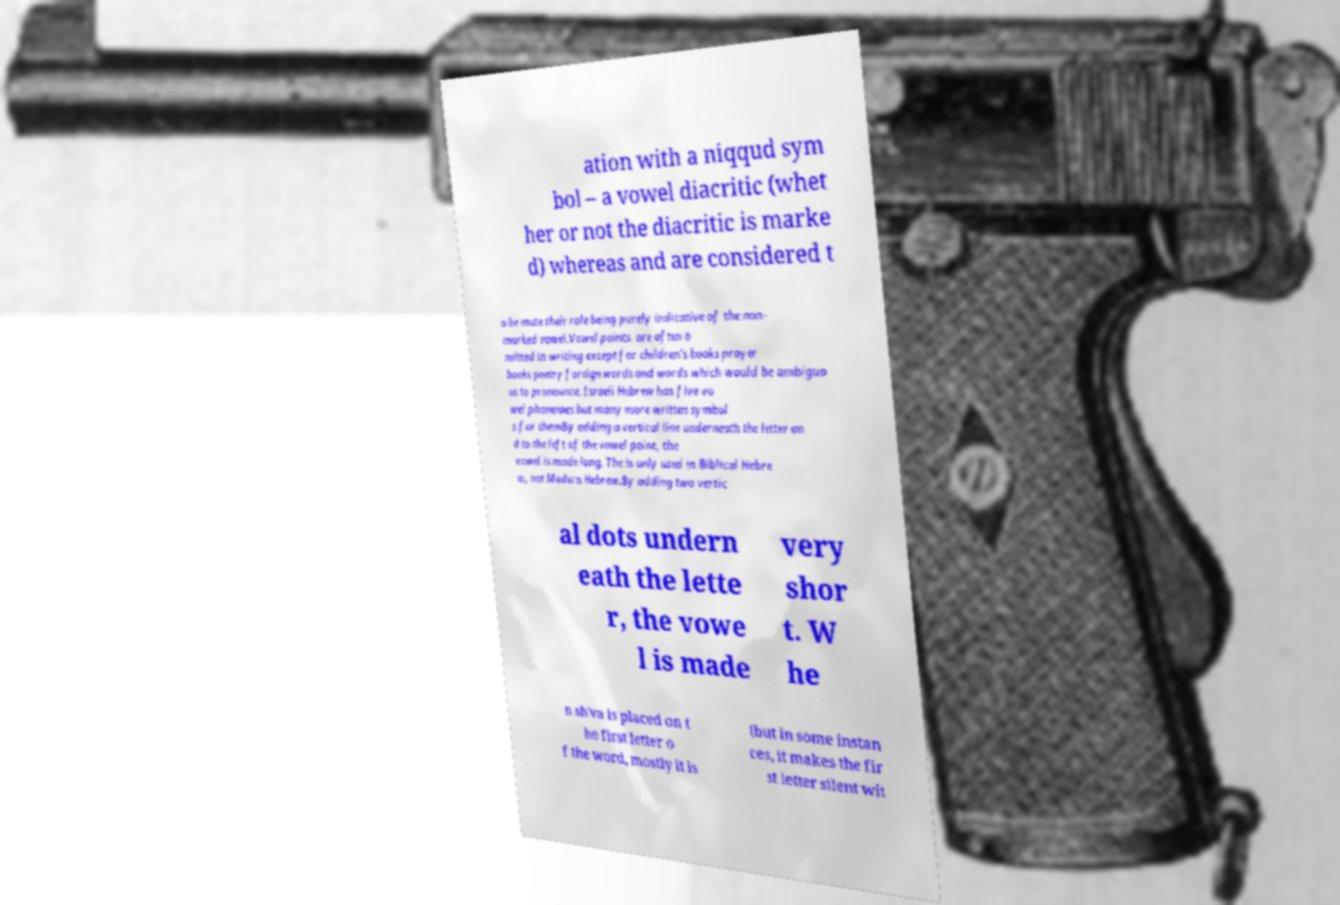Can you read and provide the text displayed in the image?This photo seems to have some interesting text. Can you extract and type it out for me? ation with a niqqud sym bol – a vowel diacritic (whet her or not the diacritic is marke d) whereas and are considered t o be mute their role being purely indicative of the non- marked vowel.Vowel points. are often o mitted in writing except for children's books prayer books poetry foreign words and words which would be ambiguo us to pronounce. Israeli Hebrew has five vo wel phonemes but many more written symbol s for themBy adding a vertical line underneath the letter an d to the left of the vowel point, the vowel is made long. The is only used in Biblical Hebre w, not Modern Hebrew.By adding two vertic al dots undern eath the lette r, the vowe l is made very shor t. W he n sh'va is placed on t he first letter o f the word, mostly it is (but in some instan ces, it makes the fir st letter silent wit 